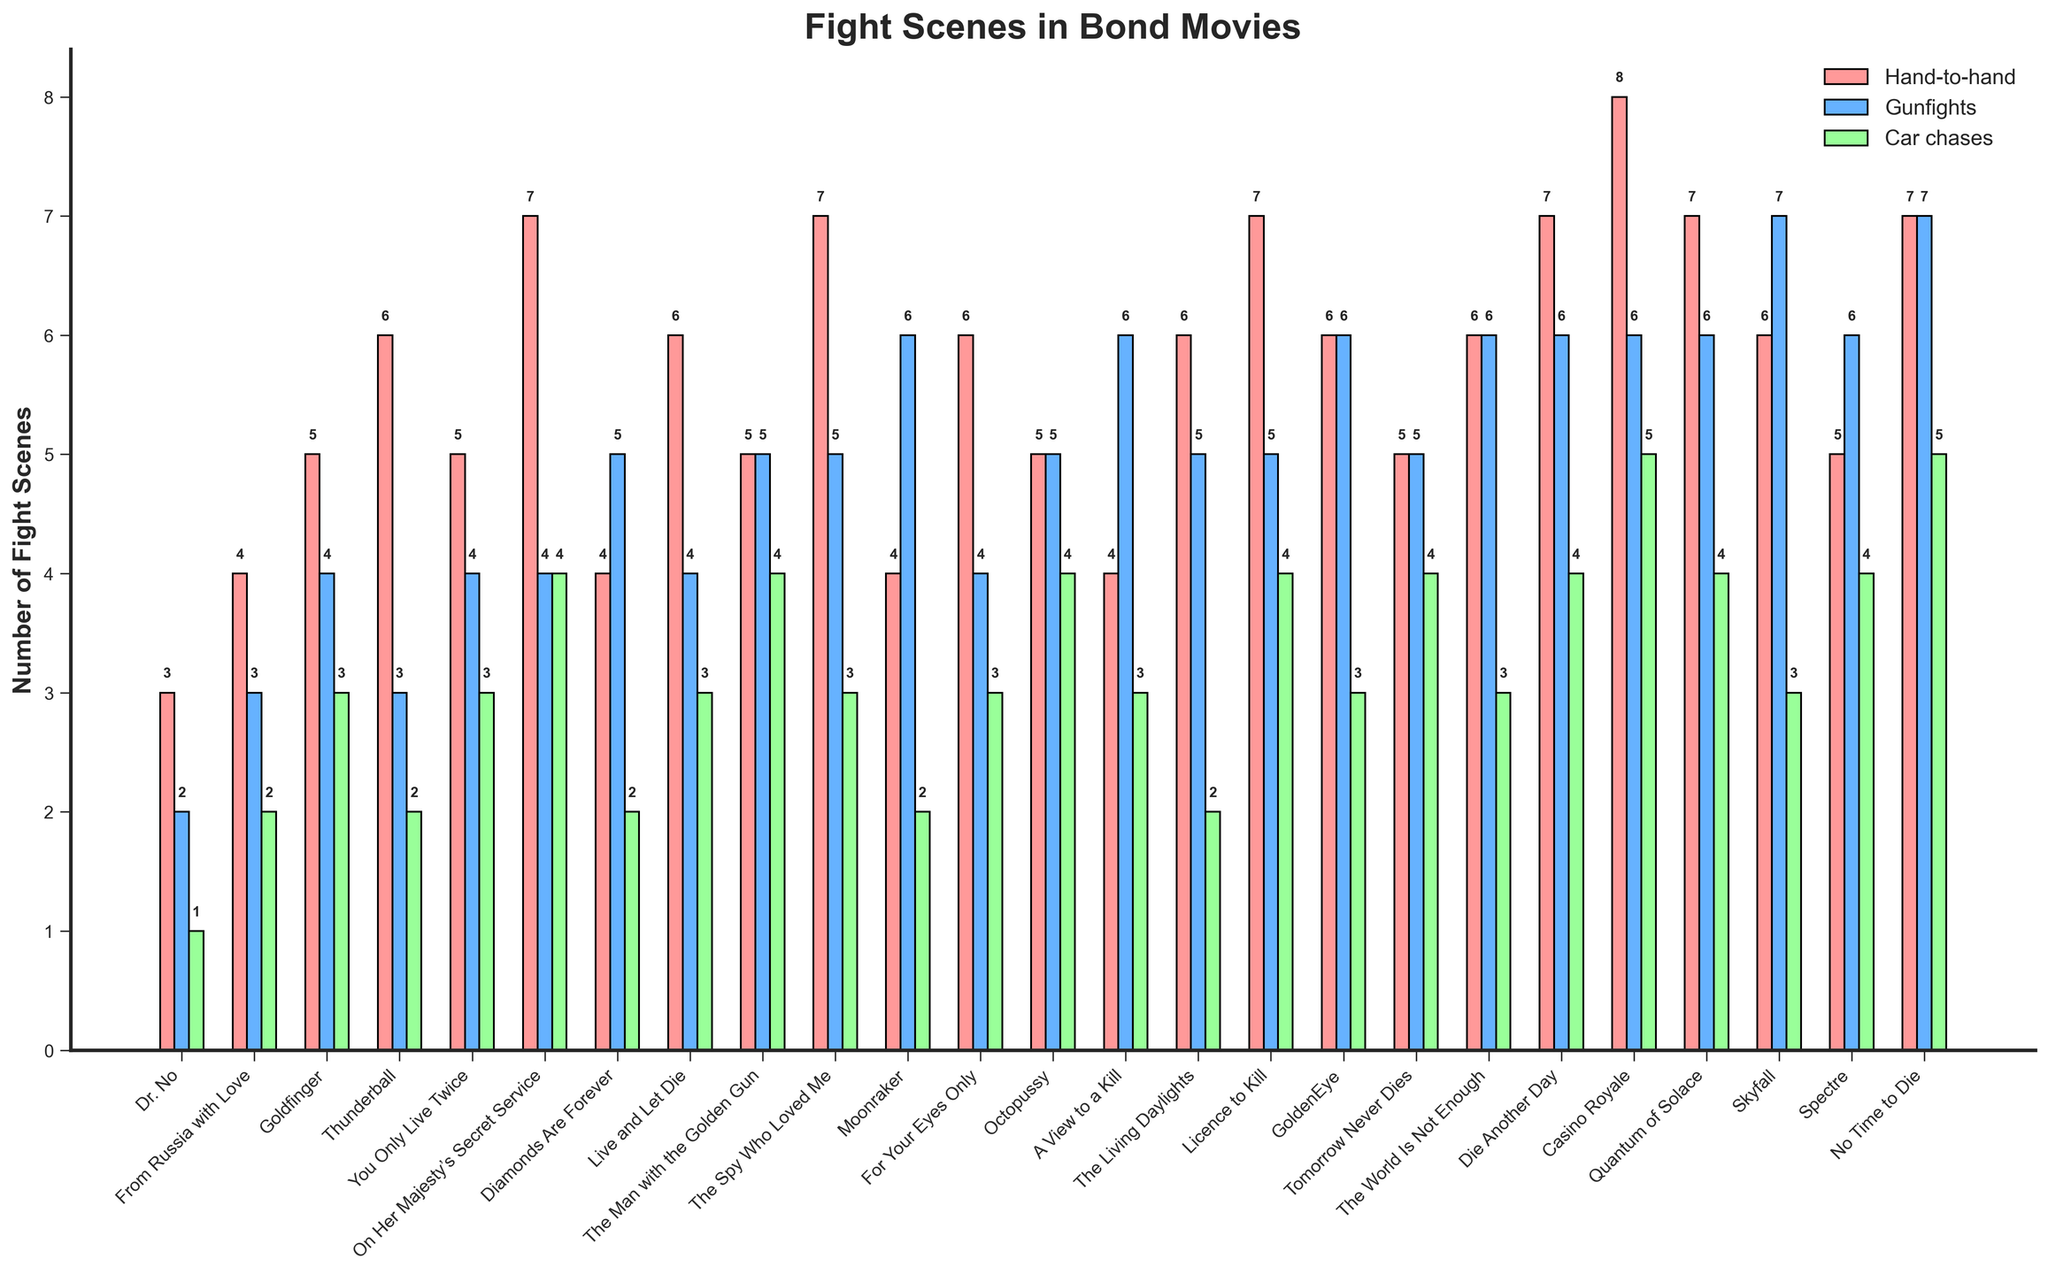What's the title of the figure? The title of the figure is located at the top and is usually in a bold format to highlight the subject of the data being represented. The title in this case is "Fight Scenes in Bond Movies".
Answer: Fight Scenes in Bond Movies Which movie has the most hand-to-hand scenes? To find this, refer to the bar representing hand-to-hand scenes (colored in pink) for each movie. "Casino Royale" has the highest value at 8.
Answer: Casino Royale What is the total number of fight scenes in "Skyfall"? Sum the values of hand-to-hand (6), gunfights (7), and car chases (3) fight scenes for "Skyfall". 6 + 7 + 3 = 16.
Answer: 16 Between "GoldenEye" and "The World Is Not Enough", which movie has more car chase scenes? Compare the height of the green bars representing car chases for both movies. Both have the same number of car chases, which is 3.
Answer: Equal What is the average number of hand-to-hand combat scenes across all movies? Sum the hand-to-hand combat scenes for all movies and divide by the number of movies (25). Total is 147. Thus, 147 ÷ 25 = approximately 5.88.
Answer: Approximately 5.88 Which movie has the least number of gunfights? Identify the shortest blue bar representing gunfights. "Dr. No" has the least with 2 gunfights.
Answer: Dr. No In how many movies does the number of car chase scenes exceed 3? Count the number of green bars that are above the value of 3. A total of 7 movies have more than 3 car chase scenes.
Answer: 7 What is the difference in the number of hand-to-hand combat scenes between "Goldfinger" and "Dr. No"? Subtract the number of hand-to-hand combat scenes in "Dr. No" (3) from "Goldfinger" (5), which results in 2.
Answer: 2 Which movie has the highest total number of fight scenes? To find this, sum up the hand-to-hand, gunfights, and car chases for each movie and compare the totals. "No Time to Die" has the highest total at 19 (7 hand-to-hand, 7 gunfights, 5 car chases).
Answer: No Time to Die Are there more gunfights in "Moonraker" or "Quantum of Solace"? Compare the height of the blue bars for these two movies. "Moonraker" has 6 gunfights while "Quantum of Solace" has 6 as well.
Answer: Equal 